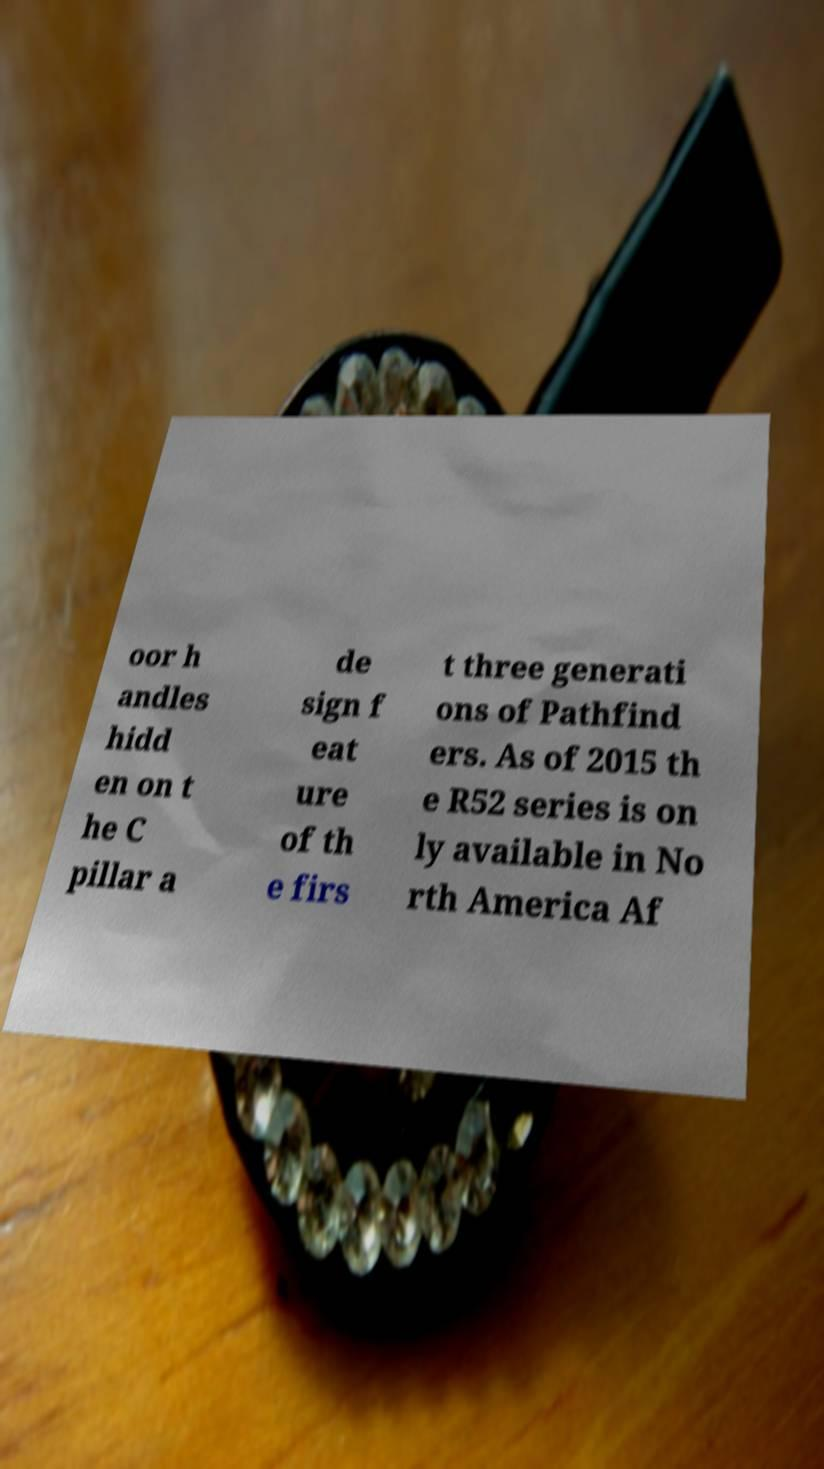There's text embedded in this image that I need extracted. Can you transcribe it verbatim? oor h andles hidd en on t he C pillar a de sign f eat ure of th e firs t three generati ons of Pathfind ers. As of 2015 th e R52 series is on ly available in No rth America Af 